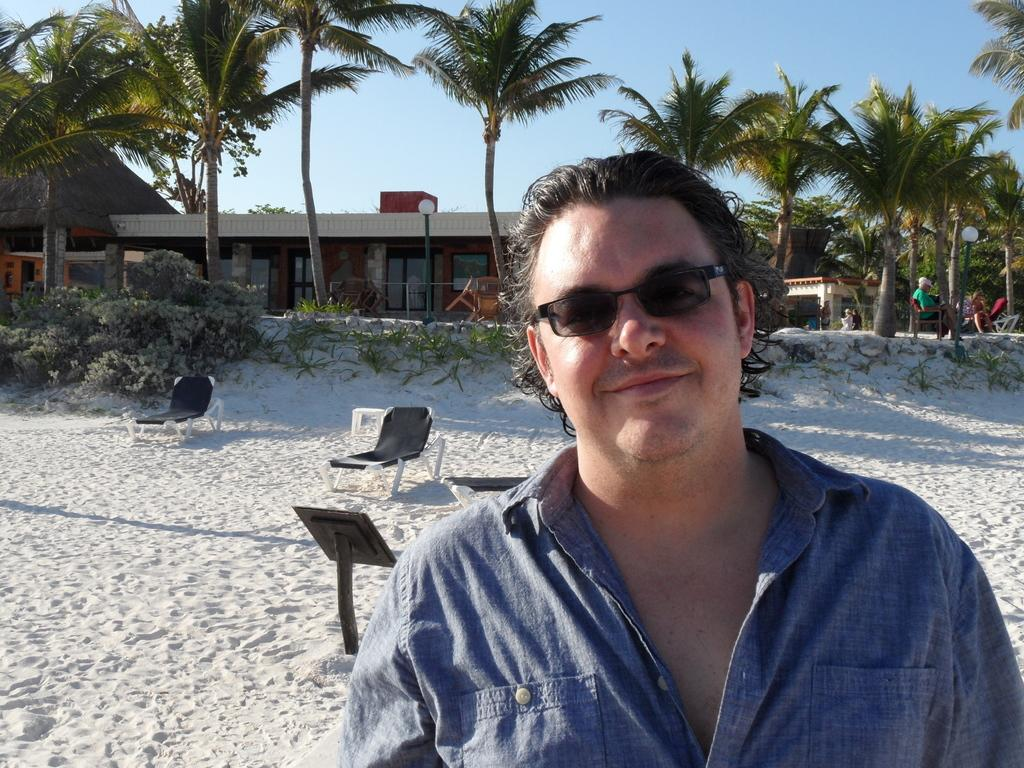What is the main subject of the image? There is a man standing in the image. Can you describe the man's appearance? The man is wearing glasses. What type of furniture is present in the image? There are chairs in the image. What type of vegetation can be seen in the image? There are plants and trees in the image. What type of structure is visible in the image? There is a house in the image. What is visible at the top of the image? The sky is blue and visible at the top of the image. What type of card is the grandmother holding in the image? There is no grandmother or card present in the image. How is the pail being used in the image? There is no pail present in the image. 